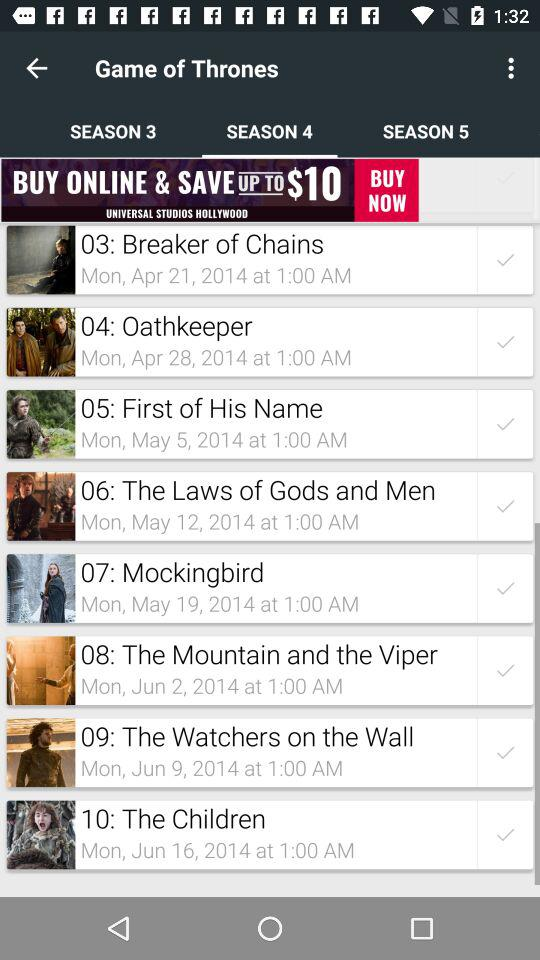What is the date and time of the "Oathkeeper"? The date of the "Oathkeeper" is Monday, April 28, 2014 and the time is 1:00 AM. 